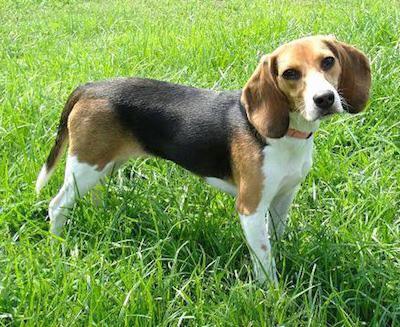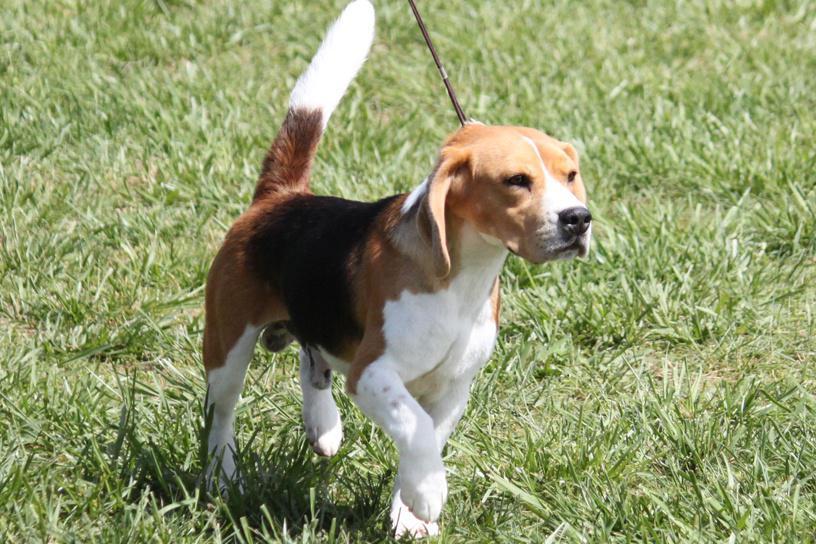The first image is the image on the left, the second image is the image on the right. Analyze the images presented: Is the assertion "In the right image the dog is facing right, and in the left image the dog is facing left." valid? Answer yes or no. No. 